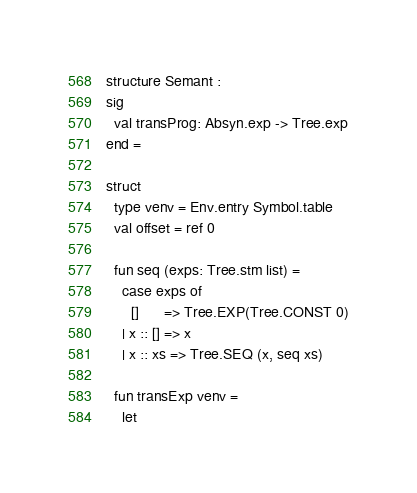<code> <loc_0><loc_0><loc_500><loc_500><_SML_>structure Semant :
sig
  val transProg: Absyn.exp -> Tree.exp
end =

struct
  type venv = Env.entry Symbol.table
  val offset = ref 0

  fun seq (exps: Tree.stm list) =
    case exps of
      []      => Tree.EXP(Tree.CONST 0)
    | x :: [] => x
    | x :: xs => Tree.SEQ (x, seq xs)

  fun transExp venv =
    let</code> 